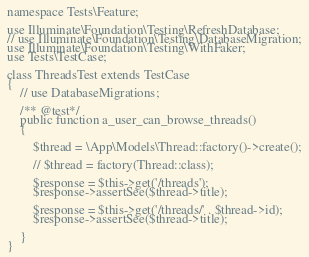Convert code to text. <code><loc_0><loc_0><loc_500><loc_500><_PHP_>
namespace Tests\Feature;

use Illuminate\Foundation\Testing\RefreshDatabase;
// use Illuminate\Foundation\Testing\DatabaseMigration;
use Illuminate\Foundation\Testing\WithFaker;
use Tests\TestCase;

class ThreadsTest extends TestCase
{
    // use DatabaseMigrations;

    /** @test*/
    public function a_user_can_browse_threads()
    {

        $thread = \App\Models\Thread::factory()->create();

        // $thread = factory(Thread::class);

        $response = $this->get('/threads');
        $response->assertSee($thread->title);

        $response = $this->get('/threads/' . $thread->id);
        $response->assertSee($thread->title);

    }
}
</code> 